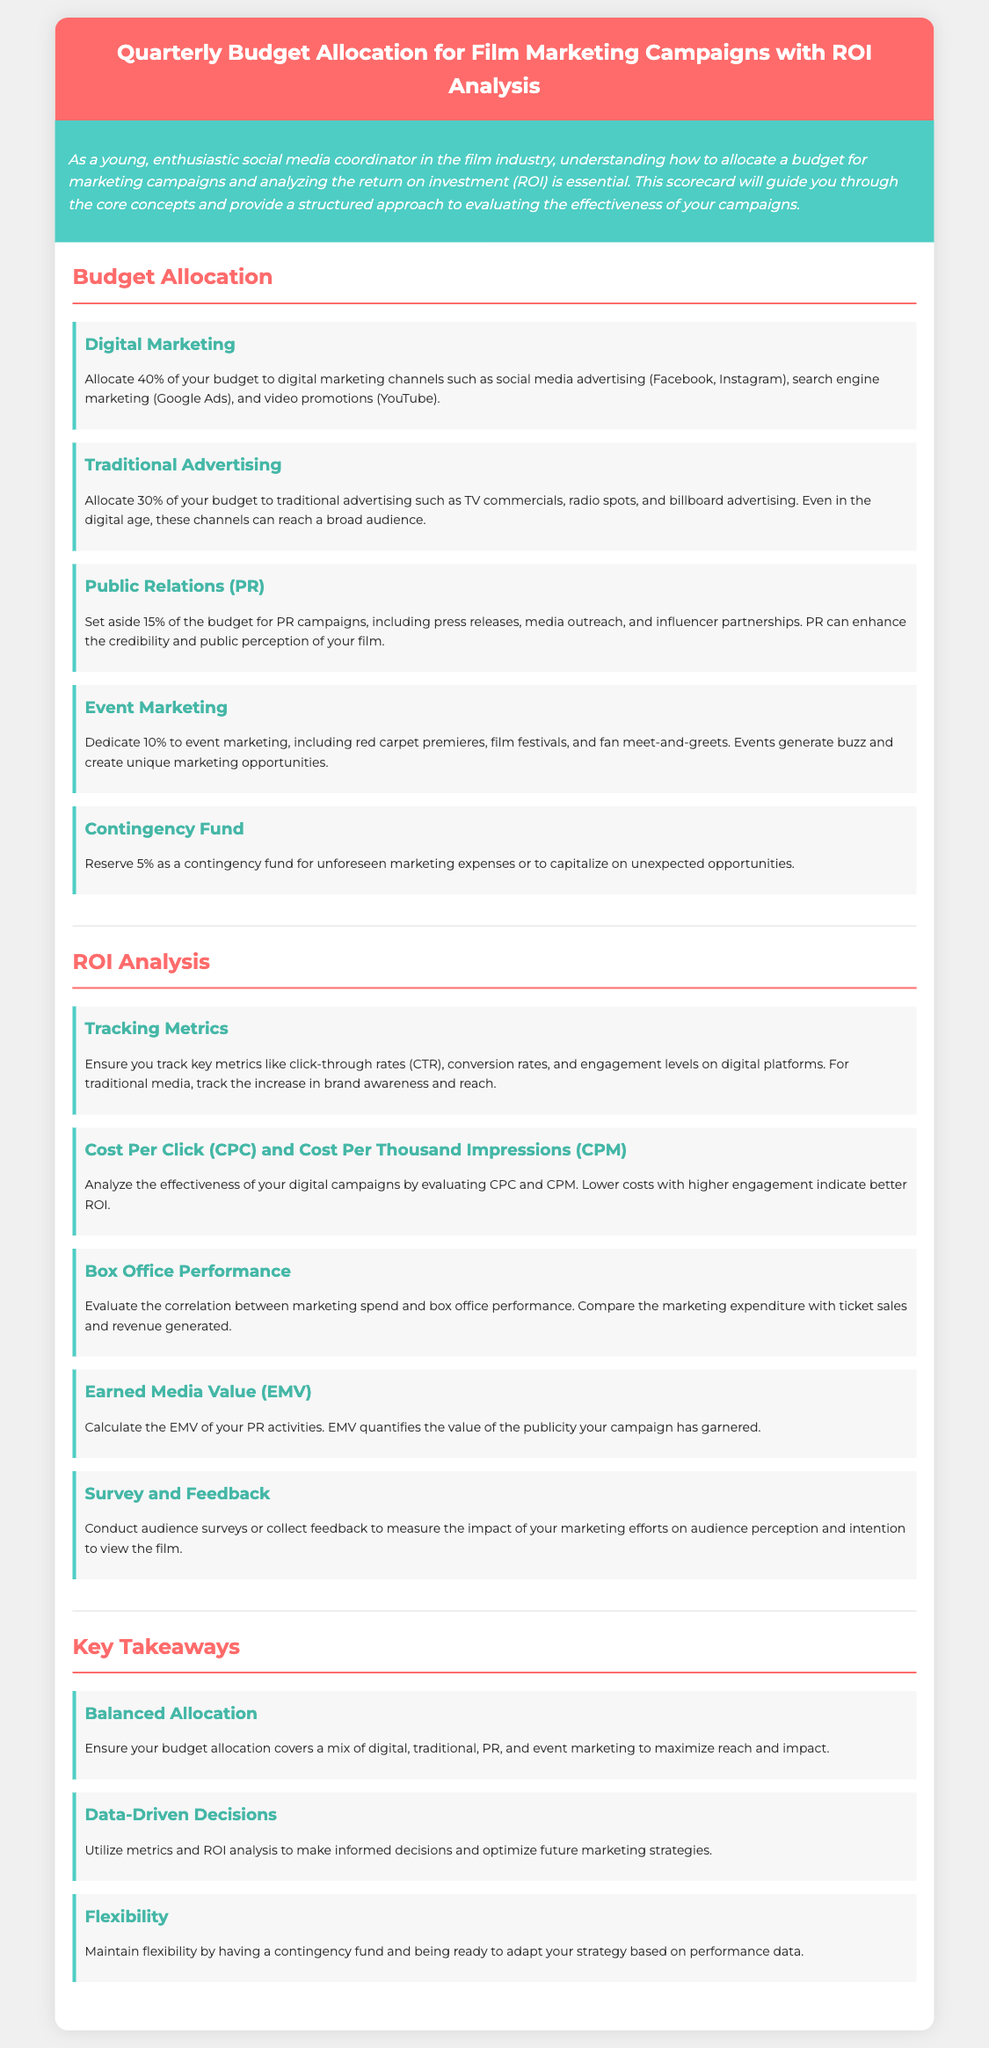what percentage of the budget is allocated to digital marketing? The document states that 40% of the budget should be allocated to digital marketing channels.
Answer: 40% what is the allocation for traditional advertising? The document indicates a 30% allocation for traditional advertising, covering TV, radio, and billboards.
Answer: 30% which aspect receives the smallest budget allocation? The document specifies that the contingency fund receives the smallest allocation of 5%.
Answer: 5% what key metric should be tracked for digital platforms? The document highlights the importance of tracking click-through rates (CTR) as a key metric for digital platforms.
Answer: click-through rates how should the success of PR campaigns be measured? The document suggests calculating the Earned Media Value (EMV) to measure the success of PR campaigns.
Answer: Earned Media Value what is one reason to maintain a contingency fund? The document mentions that a contingency fund is reserved for unforeseen marketing expenses or unexpected opportunities.
Answer: unforeseen marketing expenses how much of the budget is dedicated to public relations? The document indicates that 15% of the budget is allocated to public relations campaigns.
Answer: 15% what type of analysis is recommended for marketing spend and box office performance? The document recommends evaluating the correlation between marketing spend and box office performance for effective analysis.
Answer: correlation analysis what does the document emphasize for making future marketing strategies? The document emphasizes utilizing metrics and ROI analysis for making informed decisions regarding future strategies.
Answer: metrics and ROI analysis 